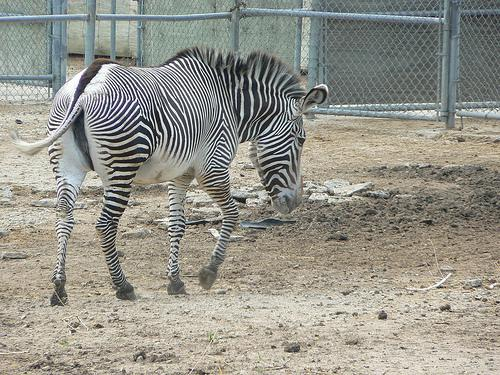Question: what is enclosing the zebra?
Choices:
A. Rock wall.
B. People.
C. A fence.
D. Hedges.
Answer with the letter. Answer: C 